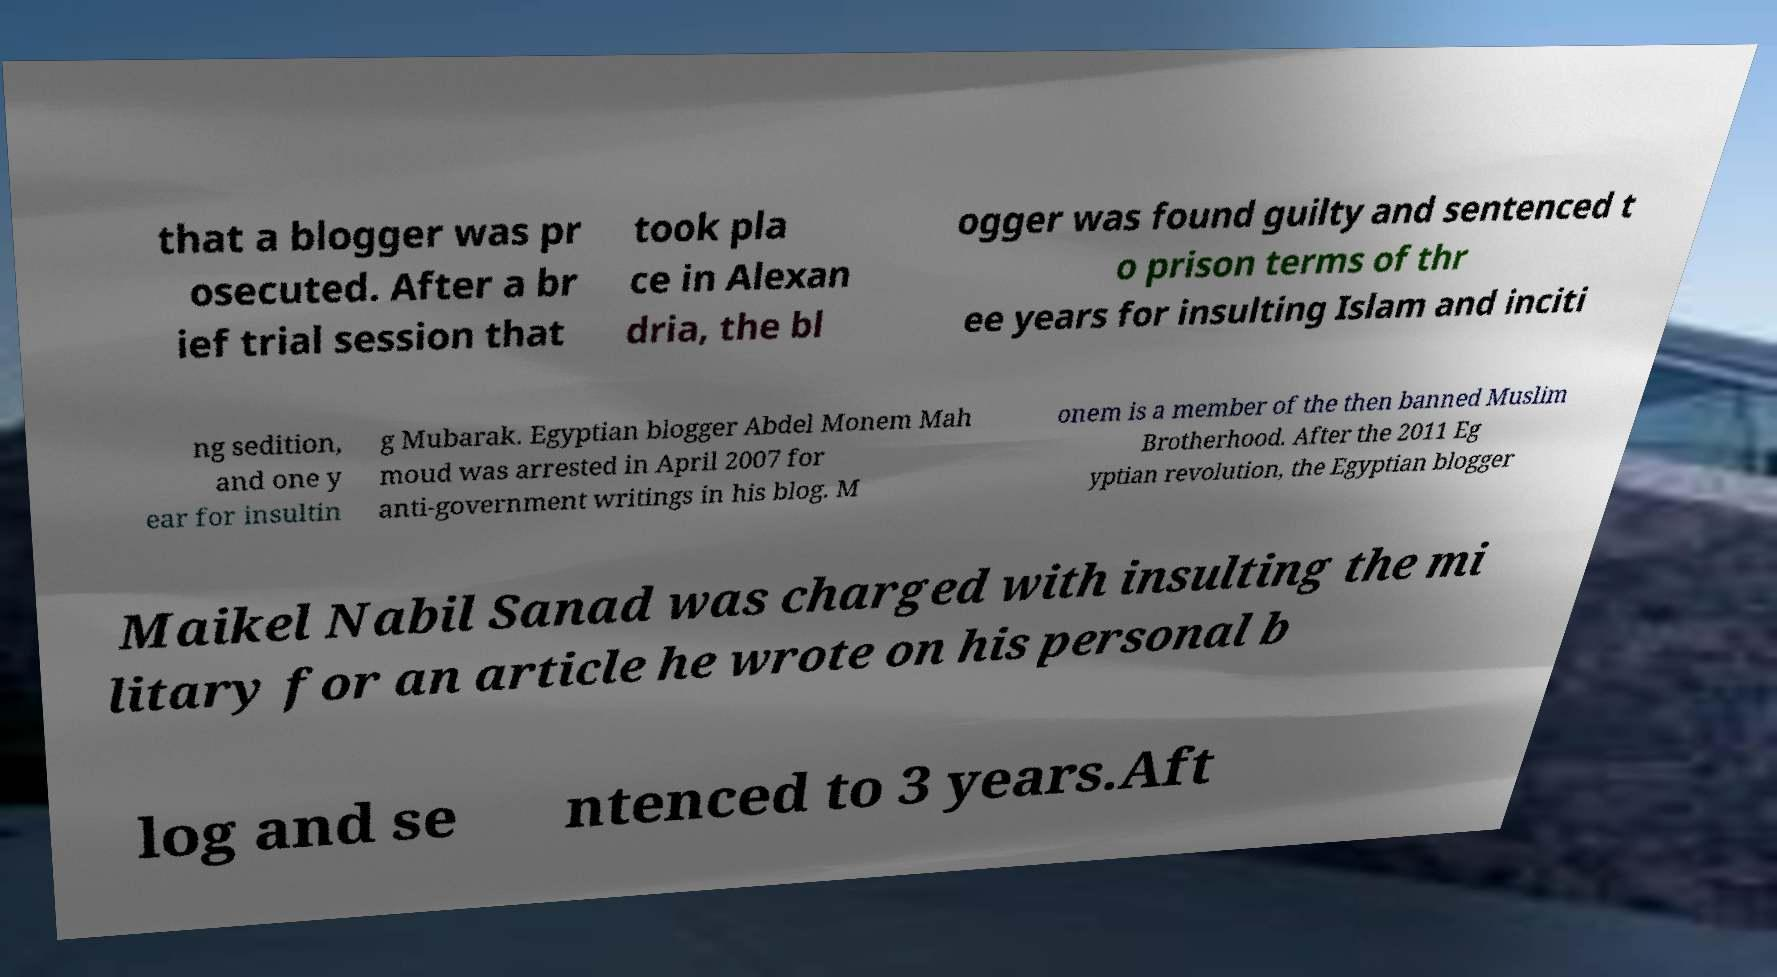Can you accurately transcribe the text from the provided image for me? that a blogger was pr osecuted. After a br ief trial session that took pla ce in Alexan dria, the bl ogger was found guilty and sentenced t o prison terms of thr ee years for insulting Islam and inciti ng sedition, and one y ear for insultin g Mubarak. Egyptian blogger Abdel Monem Mah moud was arrested in April 2007 for anti-government writings in his blog. M onem is a member of the then banned Muslim Brotherhood. After the 2011 Eg yptian revolution, the Egyptian blogger Maikel Nabil Sanad was charged with insulting the mi litary for an article he wrote on his personal b log and se ntenced to 3 years.Aft 